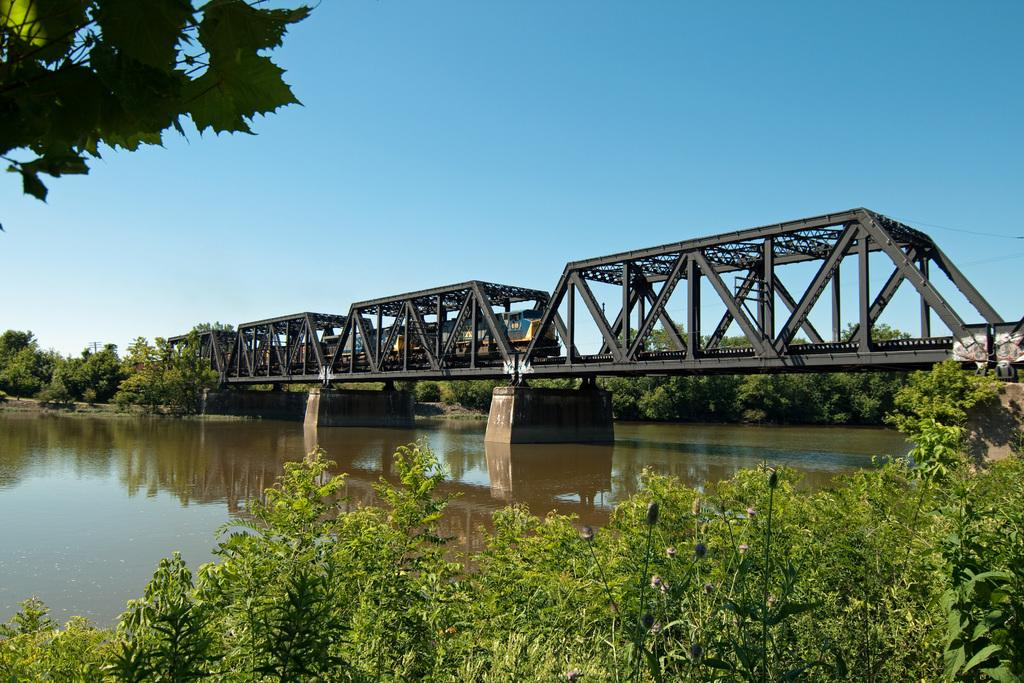What type of vegetation is at the bottom of the image? There are trees at the bottom of the image. What is happening in the middle of the image? Water is flowing in the middle of the image. What structure is present in the image? There is a bridge in the image. What is moving across the bridge in the image? A train is moving across the bridge. What is visible at the top of the image? The sky is visible at the top of the image. Can you see the tail of the elephant in the image? There is no elephant, and therefore no tail, present in the image. What type of seat is on the train in the image? The image does not show the interior of the train, so it is impossible to determine the type of seat. 